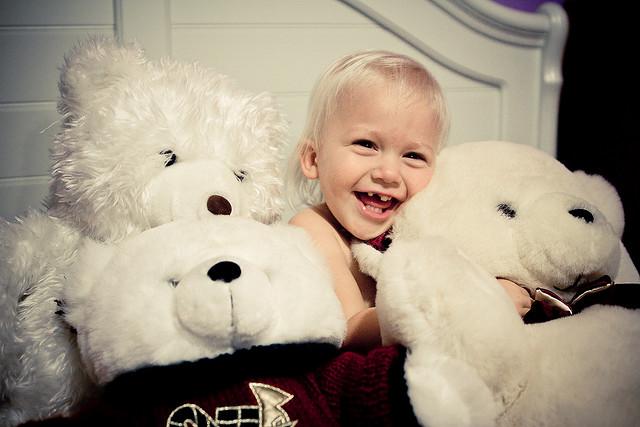Is the child smiling?
Write a very short answer. Yes. What is the child's mouth missing?
Write a very short answer. Tooth. Are all of the teddy bears white?
Give a very brief answer. Yes. 